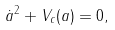<formula> <loc_0><loc_0><loc_500><loc_500>\dot { a } ^ { 2 } + V _ { c } ( a ) = 0 ,</formula> 